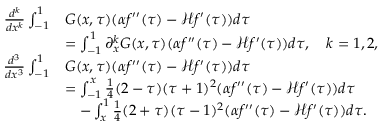Convert formula to latex. <formula><loc_0><loc_0><loc_500><loc_500>\begin{array} { r l } { \frac { d ^ { k } } { d x ^ { k } } \int _ { - 1 } ^ { 1 } } & { G ( x , \tau ) ( \alpha f ^ { \prime \prime } ( \tau ) - \mathcal { H } f ^ { \prime } ( \tau ) ) d \tau } \\ & { = \int _ { - 1 } ^ { 1 } \partial _ { x } ^ { k } G ( x , \tau ) ( \alpha f ^ { \prime \prime } ( \tau ) - \mathcal { H } f ^ { \prime } ( \tau ) ) d \tau , \quad k = 1 , 2 , } \\ { \frac { d ^ { 3 } } { d x ^ { 3 } } \int _ { - 1 } ^ { 1 } } & { G ( x , \tau ) ( \alpha f ^ { \prime \prime } ( \tau ) - \mathcal { H } f ^ { \prime } ( \tau ) ) d \tau } \\ & { = \int _ { - 1 } ^ { x } \frac { 1 } { 4 } ( 2 - \tau ) ( \tau + 1 ) ^ { 2 } ( \alpha f ^ { \prime \prime } ( \tau ) - \mathcal { H } f ^ { \prime } ( \tau ) ) d \tau } \\ & { \quad - \int _ { x } ^ { 1 } \frac { 1 } { 4 } ( 2 + \tau ) ( \tau - 1 ) ^ { 2 } ( \alpha f ^ { \prime \prime } ( \tau ) - \mathcal { H } f ^ { \prime } ( \tau ) ) d \tau . } \end{array}</formula> 